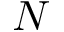<formula> <loc_0><loc_0><loc_500><loc_500>N</formula> 